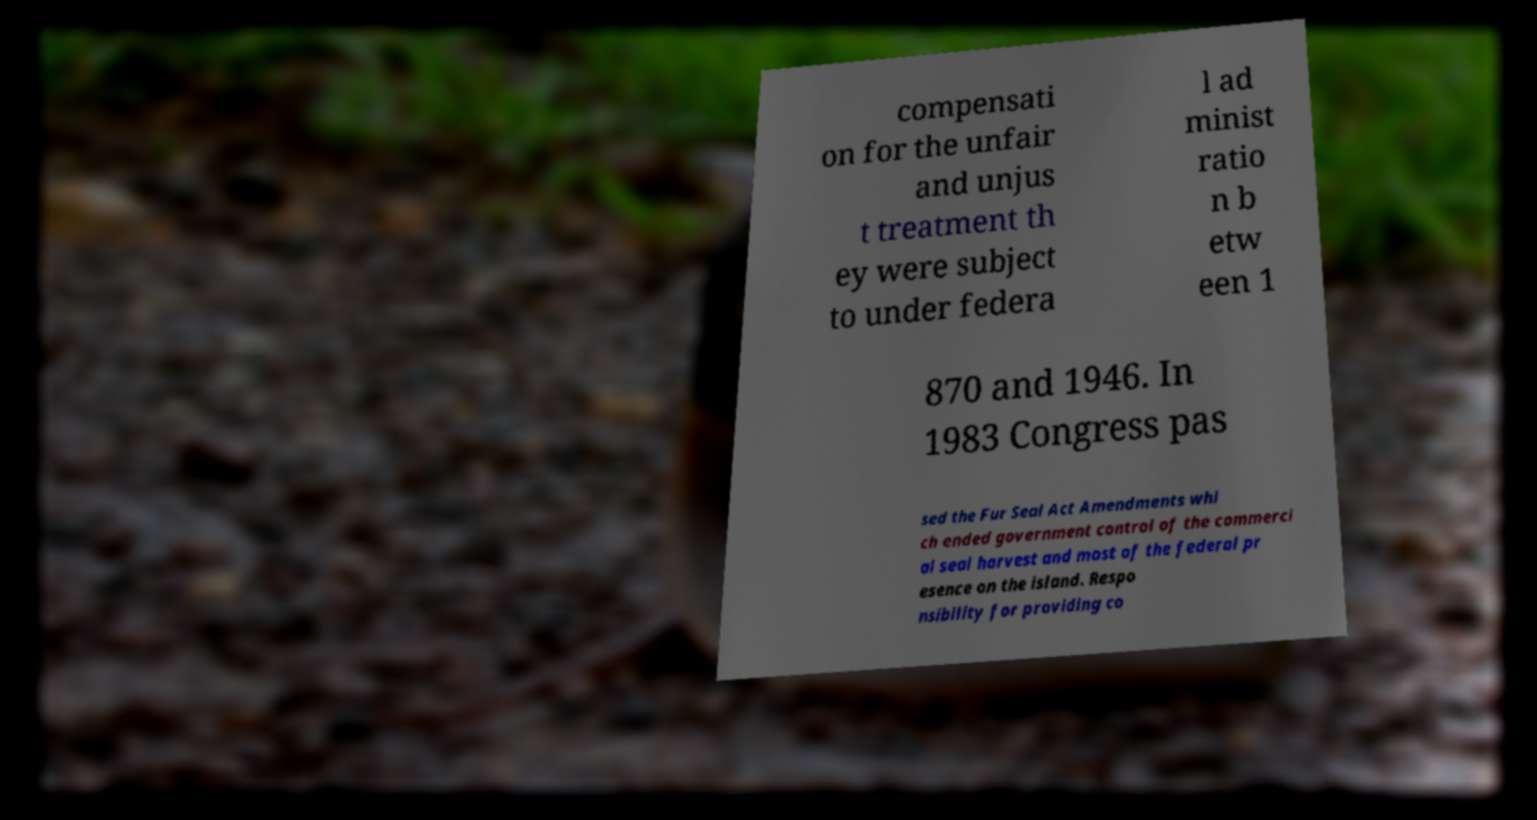Can you accurately transcribe the text from the provided image for me? compensati on for the unfair and unjus t treatment th ey were subject to under federa l ad minist ratio n b etw een 1 870 and 1946. In 1983 Congress pas sed the Fur Seal Act Amendments whi ch ended government control of the commerci al seal harvest and most of the federal pr esence on the island. Respo nsibility for providing co 